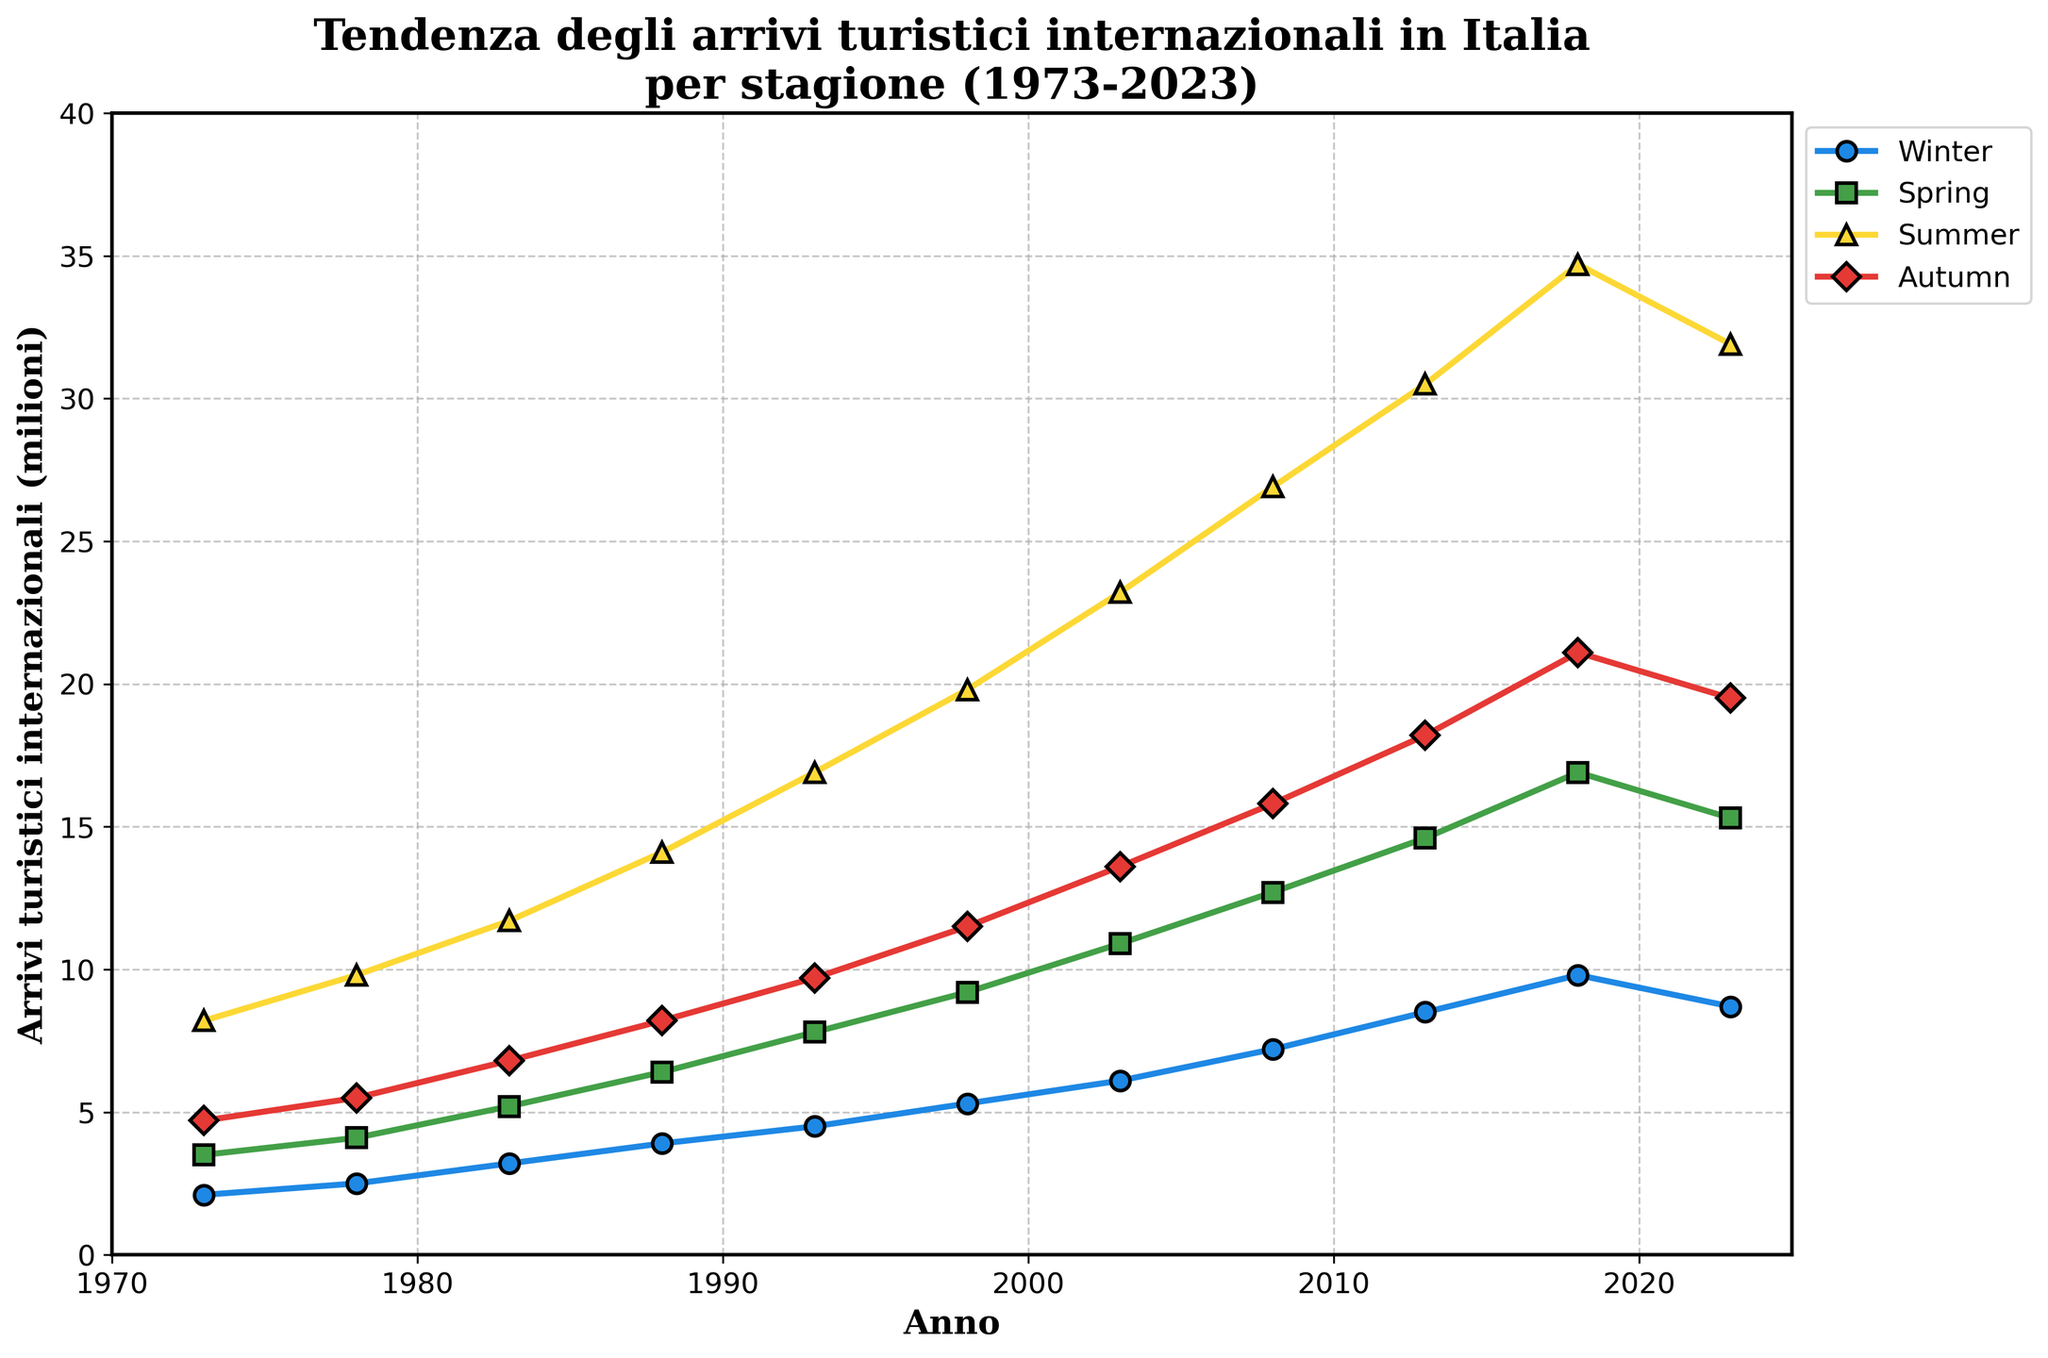What season had the highest tourist arrivals in 2023? The line chart shows different seasons with different colored lines, indicating the number of tourist arrivals. In 2023, the highest point for tourist arrivals is during Summer.
Answer: Summer Between which years did the Winter season see the largest increase in tourist arrivals? By examining the Winter data points on the line chart, the largest increase happened between 2008 and 2013, rising from 7.2 million to 8.5 million.
Answer: 2008 and 2013 Which season had more tourist arrivals in 2023, Winter or Autumn? Comparing the 2023 data points for Winter and Autumn, Winter had 8.7 million arrivals while Autumn had 19.5 million. Hence, Autumn had more arrivals than Winter.
Answer: Autumn During which year did Summer first surpass 20 million tourist arrivals? Inspect the data points for the Summer line, which crossed 20 million tourist arrivals between 1998 (19.8 million) and 2003 (23.2 million). Therefore, 2003 is the year.
Answer: 2003 What is the average number of tourist arrivals in Spring from 1988 to 2008? Spring arrivals in the given years are: 6.4 (1988), 7.8 (1993), 9.2 (1998), 10.9 (2003), and 12.7 (2008). The average is (6.4 + 7.8 + 9.2 + 10.9 + 12.7) / 5 = 9.4 million.
Answer: 9.4 million How much did tourist arrivals increase in Summer from 1973 to 2023? In 1973, Summer had 8.2 million arrivals. By 2023, this increased to 31.9 million. The increase is 31.9 - 8.2 = 23.7 million.
Answer: 23.7 million Which year had the smallest difference in tourist arrivals between Spring and Autumn? Examine the differences for each year: 
1973: 4.7-3.5=1.2 
1978: 5.5-4.1=1.4 
1983: 6.8-5.2=1.6 
1988: 8.2-6.4=1.8 
1993: 9.7-7.8=1.9 
1998: 11.5-9.2=2.3 
2003: 13.6-10.9=2.7 
2008: 15.8-12.7=3.1 
2013: 18.2-14.6=3.6 
2018: 21.1-16.9=4.2 
2023: 19.5-15.3=4.2 
1973 has the smallest difference (1.2 million).
Answer: 1973 Which season saw a peak number of tourist arrivals in 2018, and how many arrivals were there? By checking the highest point for each season in 2018, Summer peaked at 34.7 million arrivals.
Answer: Summer, 34.7 million 